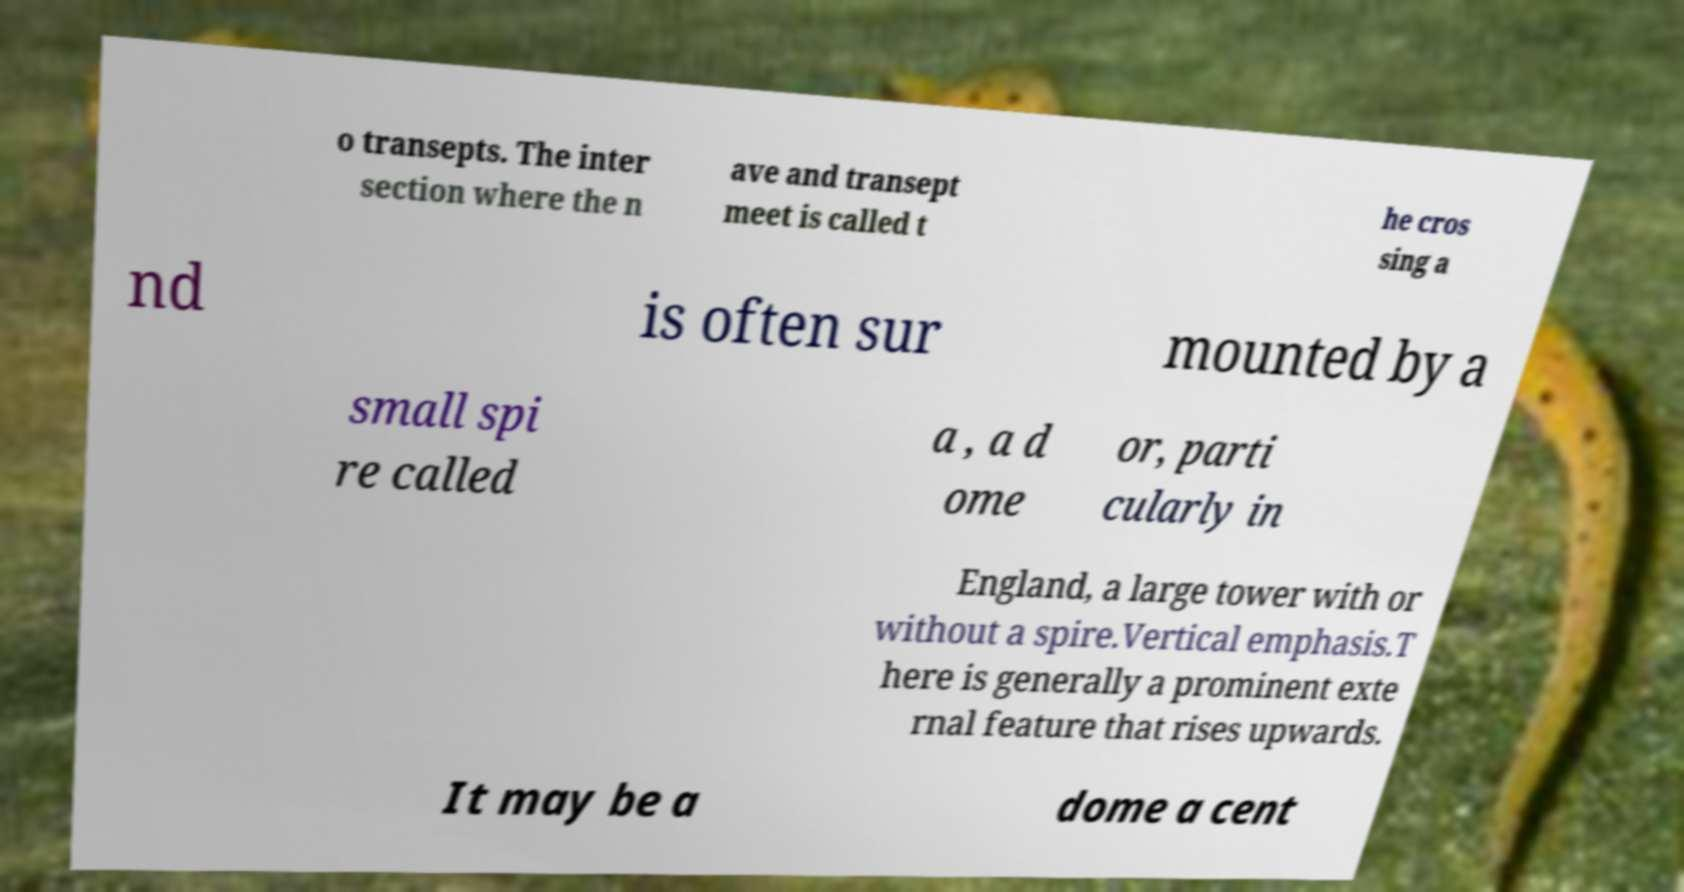There's text embedded in this image that I need extracted. Can you transcribe it verbatim? o transepts. The inter section where the n ave and transept meet is called t he cros sing a nd is often sur mounted by a small spi re called a , a d ome or, parti cularly in England, a large tower with or without a spire.Vertical emphasis.T here is generally a prominent exte rnal feature that rises upwards. It may be a dome a cent 